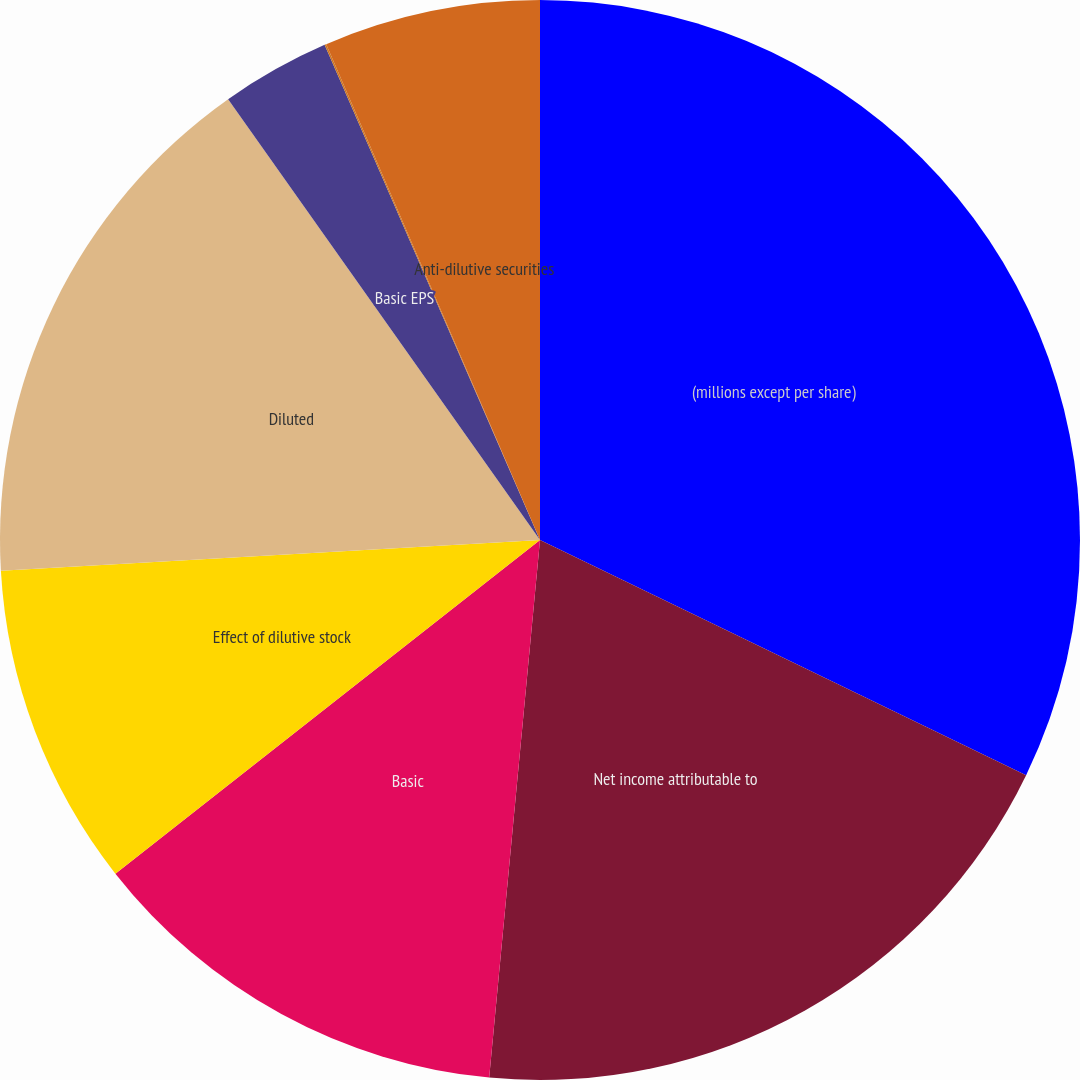Convert chart. <chart><loc_0><loc_0><loc_500><loc_500><pie_chart><fcel>(millions except per share)<fcel>Net income attributable to<fcel>Basic<fcel>Effect of dilutive stock<fcel>Diluted<fcel>Basic EPS<fcel>Diluted EPS<fcel>Anti-dilutive securities<nl><fcel>32.17%<fcel>19.33%<fcel>12.9%<fcel>9.69%<fcel>16.11%<fcel>3.27%<fcel>0.05%<fcel>6.48%<nl></chart> 